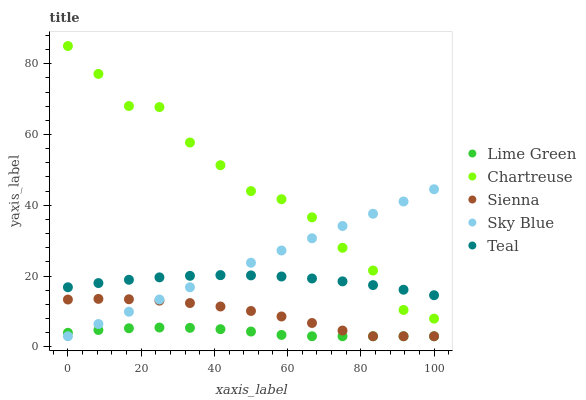Does Lime Green have the minimum area under the curve?
Answer yes or no. Yes. Does Chartreuse have the maximum area under the curve?
Answer yes or no. Yes. Does Sky Blue have the minimum area under the curve?
Answer yes or no. No. Does Sky Blue have the maximum area under the curve?
Answer yes or no. No. Is Sky Blue the smoothest?
Answer yes or no. Yes. Is Chartreuse the roughest?
Answer yes or no. Yes. Is Chartreuse the smoothest?
Answer yes or no. No. Is Sky Blue the roughest?
Answer yes or no. No. Does Sienna have the lowest value?
Answer yes or no. Yes. Does Chartreuse have the lowest value?
Answer yes or no. No. Does Chartreuse have the highest value?
Answer yes or no. Yes. Does Sky Blue have the highest value?
Answer yes or no. No. Is Lime Green less than Teal?
Answer yes or no. Yes. Is Teal greater than Sienna?
Answer yes or no. Yes. Does Sienna intersect Sky Blue?
Answer yes or no. Yes. Is Sienna less than Sky Blue?
Answer yes or no. No. Is Sienna greater than Sky Blue?
Answer yes or no. No. Does Lime Green intersect Teal?
Answer yes or no. No. 